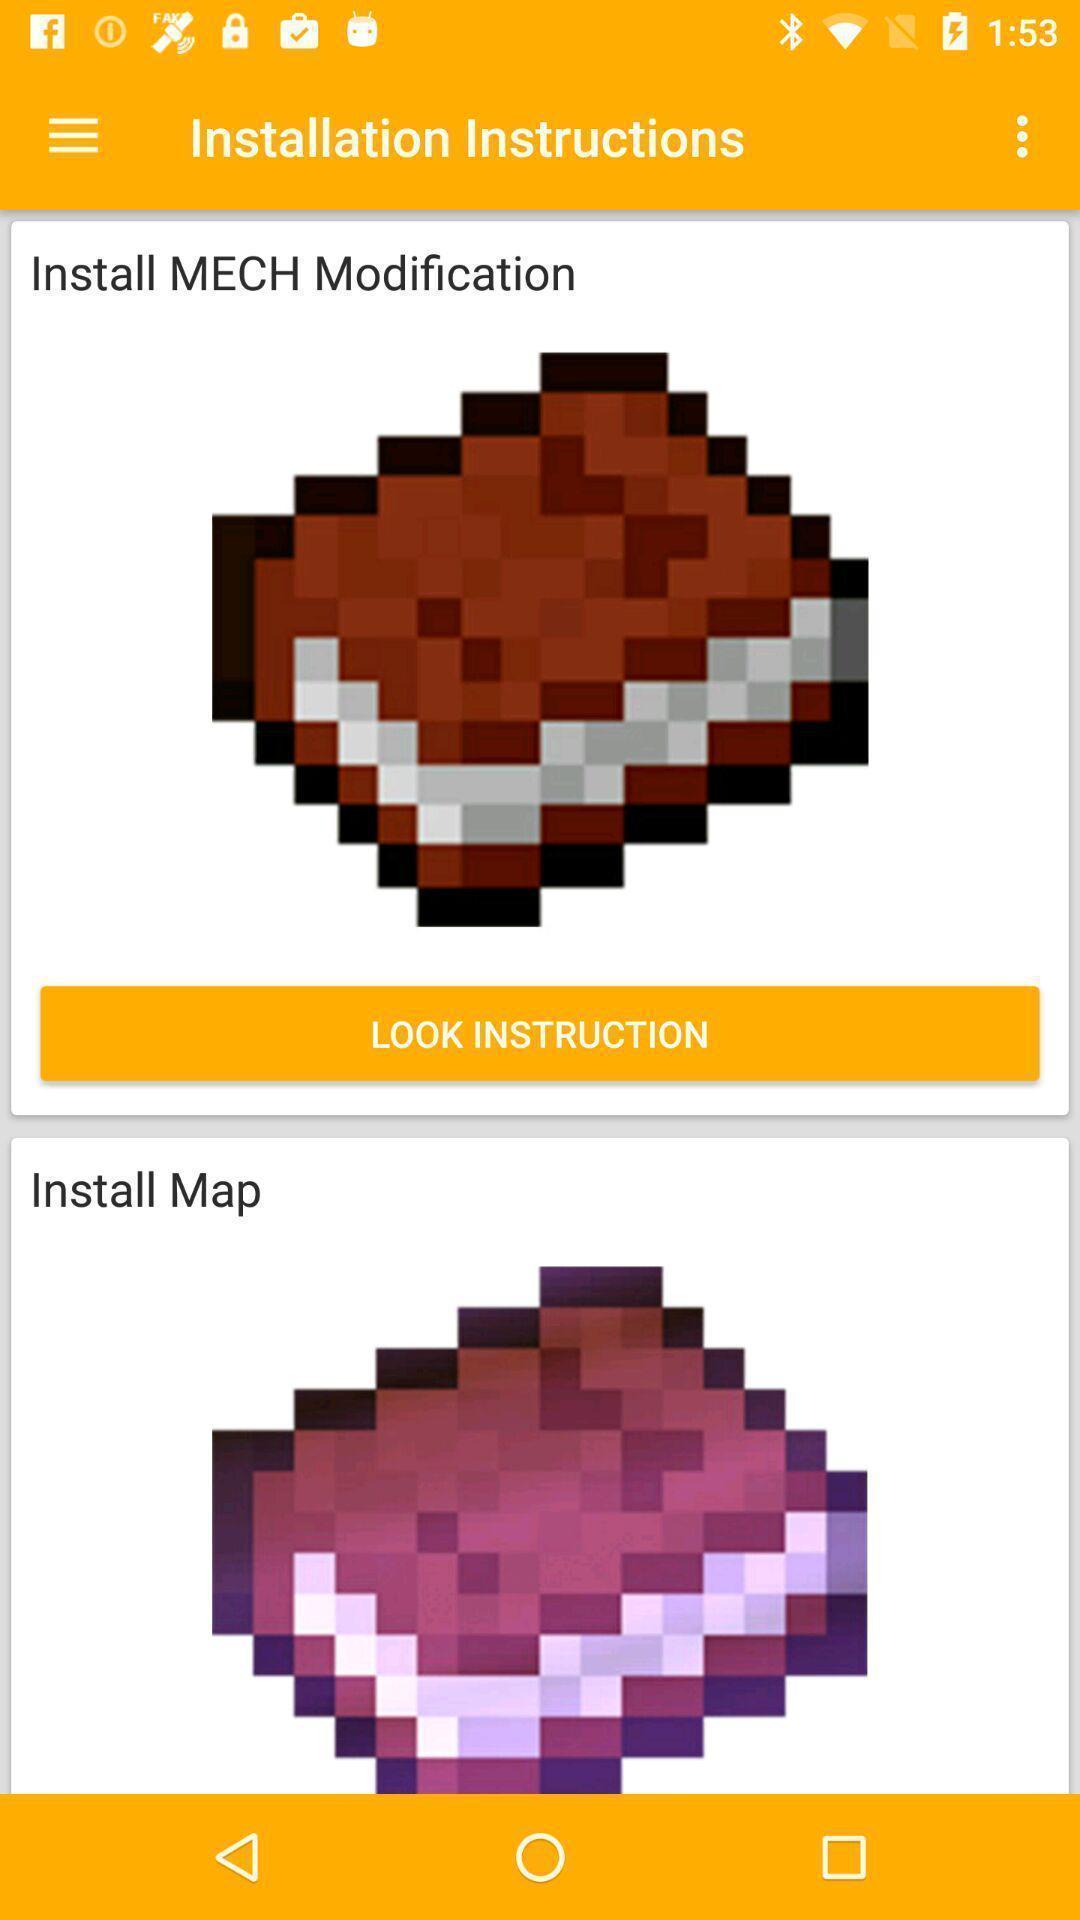Explain what's happening in this screen capture. Page displays installation instructions. 